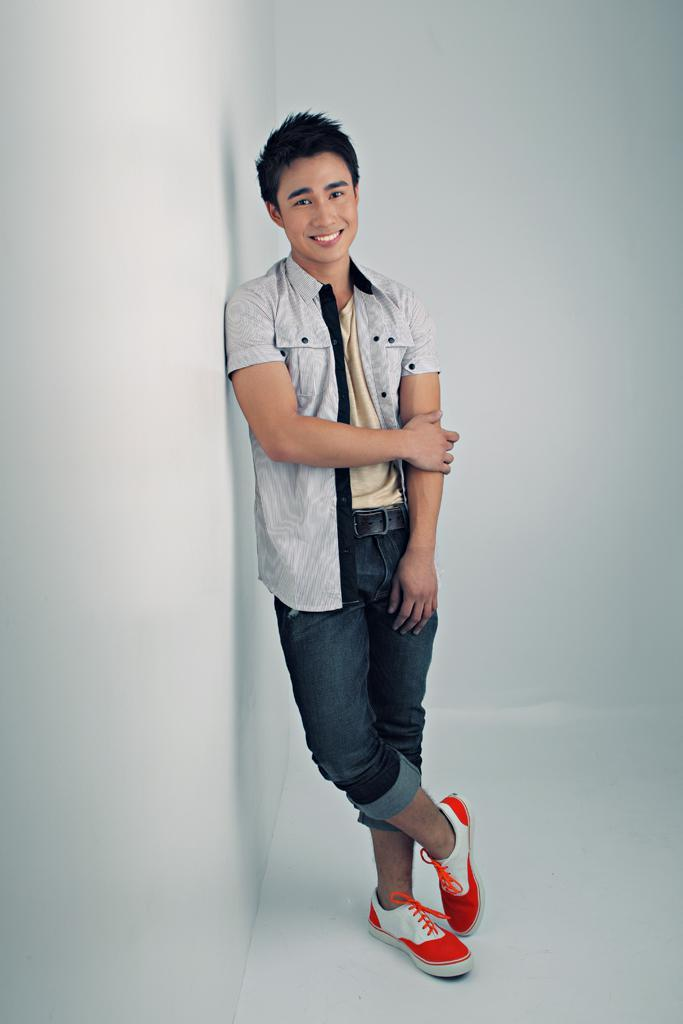Who is present in the image? There is a man in the image. What is the man doing in the image? The man is standing near a wall and smiling. What is the color of the floor in the image? The floor in the image is white. What type of horse can be seen wearing a badge in the image? There is no horse or badge present in the image; it features a man standing near a wall and smiling. 